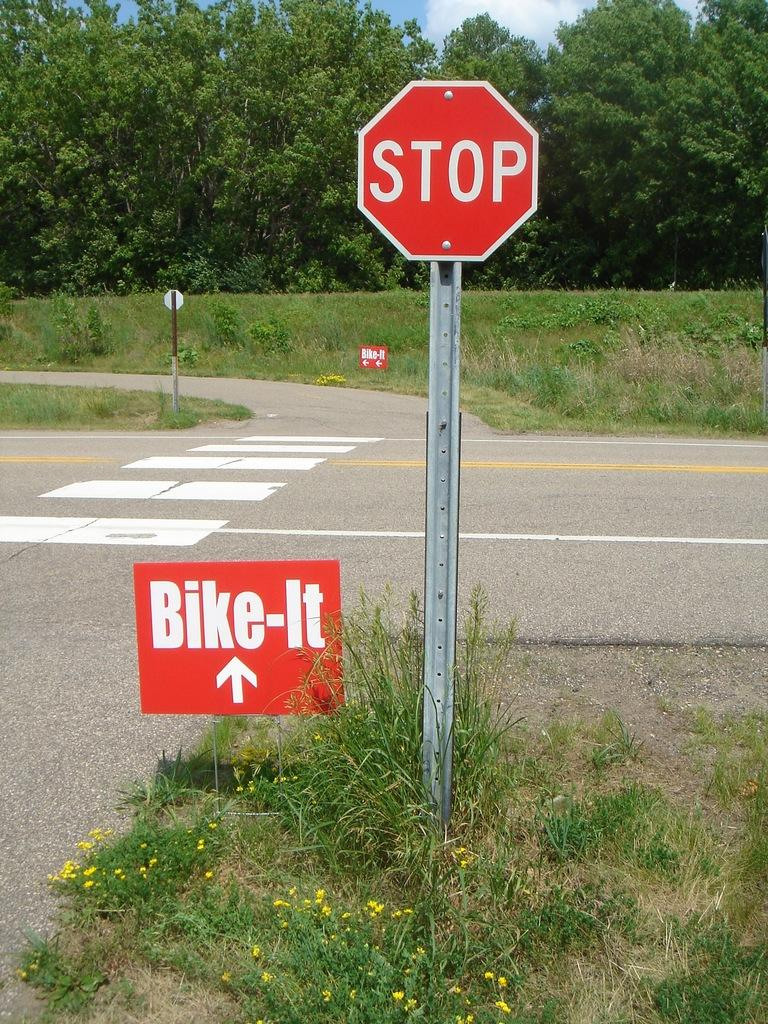<image>
Share a concise interpretation of the image provided. The stop sign is for bikers and then a sign shows where the bikers to go. 